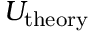<formula> <loc_0><loc_0><loc_500><loc_500>U _ { t h e o r y }</formula> 